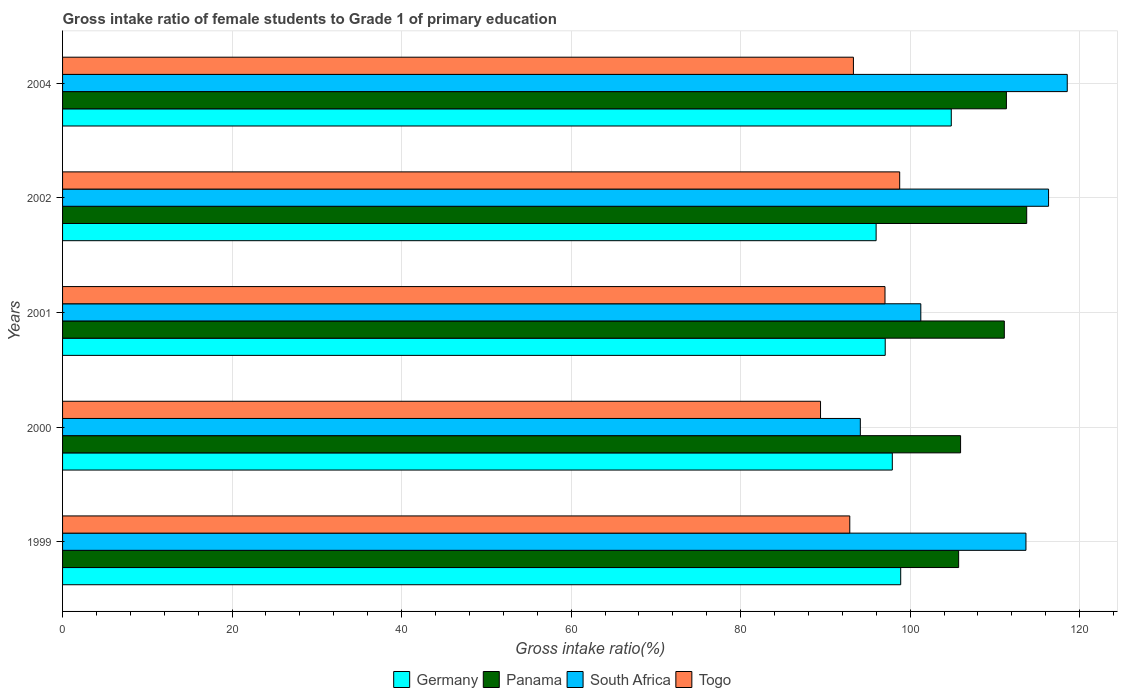How many groups of bars are there?
Make the answer very short. 5. Are the number of bars per tick equal to the number of legend labels?
Offer a very short reply. Yes. Are the number of bars on each tick of the Y-axis equal?
Your answer should be very brief. Yes. How many bars are there on the 1st tick from the top?
Make the answer very short. 4. What is the label of the 3rd group of bars from the top?
Provide a succinct answer. 2001. In how many cases, is the number of bars for a given year not equal to the number of legend labels?
Offer a terse response. 0. What is the gross intake ratio in Togo in 1999?
Provide a succinct answer. 92.88. Across all years, what is the maximum gross intake ratio in Germany?
Offer a very short reply. 104.85. Across all years, what is the minimum gross intake ratio in Panama?
Offer a very short reply. 105.72. In which year was the gross intake ratio in Togo maximum?
Offer a very short reply. 2002. In which year was the gross intake ratio in Panama minimum?
Your answer should be very brief. 1999. What is the total gross intake ratio in Germany in the graph?
Offer a terse response. 494.68. What is the difference between the gross intake ratio in Panama in 2000 and that in 2004?
Make the answer very short. -5.41. What is the difference between the gross intake ratio in Germany in 2004 and the gross intake ratio in South Africa in 2001?
Keep it short and to the point. 3.59. What is the average gross intake ratio in Togo per year?
Provide a short and direct response. 94.28. In the year 1999, what is the difference between the gross intake ratio in South Africa and gross intake ratio in Panama?
Your response must be concise. 7.94. In how many years, is the gross intake ratio in Togo greater than 48 %?
Provide a short and direct response. 5. What is the ratio of the gross intake ratio in Germany in 2001 to that in 2004?
Provide a short and direct response. 0.93. Is the gross intake ratio in Panama in 1999 less than that in 2001?
Offer a terse response. Yes. Is the difference between the gross intake ratio in South Africa in 2000 and 2002 greater than the difference between the gross intake ratio in Panama in 2000 and 2002?
Your answer should be very brief. No. What is the difference between the highest and the second highest gross intake ratio in South Africa?
Give a very brief answer. 2.21. What is the difference between the highest and the lowest gross intake ratio in Panama?
Provide a short and direct response. 8.03. In how many years, is the gross intake ratio in South Africa greater than the average gross intake ratio in South Africa taken over all years?
Your response must be concise. 3. Is the sum of the gross intake ratio in Panama in 1999 and 2004 greater than the maximum gross intake ratio in South Africa across all years?
Offer a very short reply. Yes. Is it the case that in every year, the sum of the gross intake ratio in Germany and gross intake ratio in Togo is greater than the sum of gross intake ratio in Panama and gross intake ratio in South Africa?
Provide a succinct answer. No. What does the 3rd bar from the top in 1999 represents?
Offer a very short reply. Panama. What does the 4th bar from the bottom in 2002 represents?
Your answer should be compact. Togo. How many bars are there?
Make the answer very short. 20. Does the graph contain grids?
Provide a succinct answer. Yes. How many legend labels are there?
Ensure brevity in your answer.  4. How are the legend labels stacked?
Ensure brevity in your answer.  Horizontal. What is the title of the graph?
Ensure brevity in your answer.  Gross intake ratio of female students to Grade 1 of primary education. What is the label or title of the X-axis?
Your answer should be very brief. Gross intake ratio(%). What is the Gross intake ratio(%) in Germany in 1999?
Your response must be concise. 98.89. What is the Gross intake ratio(%) of Panama in 1999?
Your answer should be very brief. 105.72. What is the Gross intake ratio(%) in South Africa in 1999?
Ensure brevity in your answer.  113.66. What is the Gross intake ratio(%) in Togo in 1999?
Your response must be concise. 92.88. What is the Gross intake ratio(%) of Germany in 2000?
Provide a short and direct response. 97.9. What is the Gross intake ratio(%) of Panama in 2000?
Make the answer very short. 105.95. What is the Gross intake ratio(%) of South Africa in 2000?
Offer a very short reply. 94.12. What is the Gross intake ratio(%) of Togo in 2000?
Offer a terse response. 89.43. What is the Gross intake ratio(%) in Germany in 2001?
Your answer should be very brief. 97.06. What is the Gross intake ratio(%) in Panama in 2001?
Offer a terse response. 111.11. What is the Gross intake ratio(%) in South Africa in 2001?
Offer a terse response. 101.26. What is the Gross intake ratio(%) in Togo in 2001?
Your answer should be compact. 97.03. What is the Gross intake ratio(%) in Germany in 2002?
Make the answer very short. 95.99. What is the Gross intake ratio(%) in Panama in 2002?
Your response must be concise. 113.75. What is the Gross intake ratio(%) in South Africa in 2002?
Ensure brevity in your answer.  116.33. What is the Gross intake ratio(%) in Togo in 2002?
Offer a terse response. 98.77. What is the Gross intake ratio(%) in Germany in 2004?
Your answer should be compact. 104.85. What is the Gross intake ratio(%) in Panama in 2004?
Ensure brevity in your answer.  111.36. What is the Gross intake ratio(%) in South Africa in 2004?
Give a very brief answer. 118.54. What is the Gross intake ratio(%) in Togo in 2004?
Ensure brevity in your answer.  93.31. Across all years, what is the maximum Gross intake ratio(%) of Germany?
Provide a short and direct response. 104.85. Across all years, what is the maximum Gross intake ratio(%) in Panama?
Give a very brief answer. 113.75. Across all years, what is the maximum Gross intake ratio(%) in South Africa?
Provide a succinct answer. 118.54. Across all years, what is the maximum Gross intake ratio(%) in Togo?
Ensure brevity in your answer.  98.77. Across all years, what is the minimum Gross intake ratio(%) in Germany?
Provide a succinct answer. 95.99. Across all years, what is the minimum Gross intake ratio(%) in Panama?
Your response must be concise. 105.72. Across all years, what is the minimum Gross intake ratio(%) in South Africa?
Provide a succinct answer. 94.12. Across all years, what is the minimum Gross intake ratio(%) of Togo?
Your answer should be compact. 89.43. What is the total Gross intake ratio(%) in Germany in the graph?
Provide a succinct answer. 494.68. What is the total Gross intake ratio(%) in Panama in the graph?
Offer a terse response. 547.89. What is the total Gross intake ratio(%) of South Africa in the graph?
Offer a terse response. 543.91. What is the total Gross intake ratio(%) in Togo in the graph?
Provide a short and direct response. 471.42. What is the difference between the Gross intake ratio(%) in Panama in 1999 and that in 2000?
Your response must be concise. -0.23. What is the difference between the Gross intake ratio(%) of South Africa in 1999 and that in 2000?
Keep it short and to the point. 19.54. What is the difference between the Gross intake ratio(%) in Togo in 1999 and that in 2000?
Your response must be concise. 3.45. What is the difference between the Gross intake ratio(%) in Germany in 1999 and that in 2001?
Your answer should be very brief. 1.83. What is the difference between the Gross intake ratio(%) in Panama in 1999 and that in 2001?
Offer a terse response. -5.39. What is the difference between the Gross intake ratio(%) of South Africa in 1999 and that in 2001?
Offer a terse response. 12.4. What is the difference between the Gross intake ratio(%) in Togo in 1999 and that in 2001?
Give a very brief answer. -4.15. What is the difference between the Gross intake ratio(%) in Germany in 1999 and that in 2002?
Give a very brief answer. 2.9. What is the difference between the Gross intake ratio(%) in Panama in 1999 and that in 2002?
Keep it short and to the point. -8.03. What is the difference between the Gross intake ratio(%) of South Africa in 1999 and that in 2002?
Provide a short and direct response. -2.67. What is the difference between the Gross intake ratio(%) in Togo in 1999 and that in 2002?
Make the answer very short. -5.89. What is the difference between the Gross intake ratio(%) of Germany in 1999 and that in 2004?
Your response must be concise. -5.97. What is the difference between the Gross intake ratio(%) in Panama in 1999 and that in 2004?
Give a very brief answer. -5.63. What is the difference between the Gross intake ratio(%) of South Africa in 1999 and that in 2004?
Make the answer very short. -4.87. What is the difference between the Gross intake ratio(%) of Togo in 1999 and that in 2004?
Offer a very short reply. -0.43. What is the difference between the Gross intake ratio(%) in Germany in 2000 and that in 2001?
Provide a succinct answer. 0.84. What is the difference between the Gross intake ratio(%) of Panama in 2000 and that in 2001?
Ensure brevity in your answer.  -5.16. What is the difference between the Gross intake ratio(%) in South Africa in 2000 and that in 2001?
Provide a succinct answer. -7.14. What is the difference between the Gross intake ratio(%) in Togo in 2000 and that in 2001?
Offer a terse response. -7.61. What is the difference between the Gross intake ratio(%) of Germany in 2000 and that in 2002?
Provide a succinct answer. 1.91. What is the difference between the Gross intake ratio(%) in Panama in 2000 and that in 2002?
Keep it short and to the point. -7.8. What is the difference between the Gross intake ratio(%) in South Africa in 2000 and that in 2002?
Make the answer very short. -22.21. What is the difference between the Gross intake ratio(%) of Togo in 2000 and that in 2002?
Your response must be concise. -9.34. What is the difference between the Gross intake ratio(%) of Germany in 2000 and that in 2004?
Give a very brief answer. -6.96. What is the difference between the Gross intake ratio(%) in Panama in 2000 and that in 2004?
Offer a terse response. -5.41. What is the difference between the Gross intake ratio(%) of South Africa in 2000 and that in 2004?
Offer a very short reply. -24.41. What is the difference between the Gross intake ratio(%) in Togo in 2000 and that in 2004?
Your response must be concise. -3.88. What is the difference between the Gross intake ratio(%) of Germany in 2001 and that in 2002?
Offer a very short reply. 1.07. What is the difference between the Gross intake ratio(%) in Panama in 2001 and that in 2002?
Your response must be concise. -2.64. What is the difference between the Gross intake ratio(%) in South Africa in 2001 and that in 2002?
Give a very brief answer. -15.07. What is the difference between the Gross intake ratio(%) in Togo in 2001 and that in 2002?
Make the answer very short. -1.73. What is the difference between the Gross intake ratio(%) of Germany in 2001 and that in 2004?
Your response must be concise. -7.79. What is the difference between the Gross intake ratio(%) in Panama in 2001 and that in 2004?
Provide a succinct answer. -0.25. What is the difference between the Gross intake ratio(%) of South Africa in 2001 and that in 2004?
Provide a short and direct response. -17.28. What is the difference between the Gross intake ratio(%) of Togo in 2001 and that in 2004?
Make the answer very short. 3.73. What is the difference between the Gross intake ratio(%) of Germany in 2002 and that in 2004?
Make the answer very short. -8.87. What is the difference between the Gross intake ratio(%) of Panama in 2002 and that in 2004?
Ensure brevity in your answer.  2.39. What is the difference between the Gross intake ratio(%) of South Africa in 2002 and that in 2004?
Ensure brevity in your answer.  -2.21. What is the difference between the Gross intake ratio(%) in Togo in 2002 and that in 2004?
Keep it short and to the point. 5.46. What is the difference between the Gross intake ratio(%) of Germany in 1999 and the Gross intake ratio(%) of Panama in 2000?
Ensure brevity in your answer.  -7.06. What is the difference between the Gross intake ratio(%) of Germany in 1999 and the Gross intake ratio(%) of South Africa in 2000?
Your answer should be compact. 4.76. What is the difference between the Gross intake ratio(%) of Germany in 1999 and the Gross intake ratio(%) of Togo in 2000?
Your answer should be very brief. 9.46. What is the difference between the Gross intake ratio(%) in Panama in 1999 and the Gross intake ratio(%) in South Africa in 2000?
Provide a short and direct response. 11.6. What is the difference between the Gross intake ratio(%) of Panama in 1999 and the Gross intake ratio(%) of Togo in 2000?
Ensure brevity in your answer.  16.3. What is the difference between the Gross intake ratio(%) of South Africa in 1999 and the Gross intake ratio(%) of Togo in 2000?
Keep it short and to the point. 24.24. What is the difference between the Gross intake ratio(%) in Germany in 1999 and the Gross intake ratio(%) in Panama in 2001?
Make the answer very short. -12.23. What is the difference between the Gross intake ratio(%) in Germany in 1999 and the Gross intake ratio(%) in South Africa in 2001?
Give a very brief answer. -2.37. What is the difference between the Gross intake ratio(%) of Germany in 1999 and the Gross intake ratio(%) of Togo in 2001?
Keep it short and to the point. 1.85. What is the difference between the Gross intake ratio(%) of Panama in 1999 and the Gross intake ratio(%) of South Africa in 2001?
Your answer should be compact. 4.46. What is the difference between the Gross intake ratio(%) of Panama in 1999 and the Gross intake ratio(%) of Togo in 2001?
Make the answer very short. 8.69. What is the difference between the Gross intake ratio(%) in South Africa in 1999 and the Gross intake ratio(%) in Togo in 2001?
Make the answer very short. 16.63. What is the difference between the Gross intake ratio(%) of Germany in 1999 and the Gross intake ratio(%) of Panama in 2002?
Give a very brief answer. -14.87. What is the difference between the Gross intake ratio(%) of Germany in 1999 and the Gross intake ratio(%) of South Africa in 2002?
Keep it short and to the point. -17.45. What is the difference between the Gross intake ratio(%) of Germany in 1999 and the Gross intake ratio(%) of Togo in 2002?
Offer a very short reply. 0.12. What is the difference between the Gross intake ratio(%) in Panama in 1999 and the Gross intake ratio(%) in South Africa in 2002?
Provide a short and direct response. -10.61. What is the difference between the Gross intake ratio(%) in Panama in 1999 and the Gross intake ratio(%) in Togo in 2002?
Offer a terse response. 6.96. What is the difference between the Gross intake ratio(%) in South Africa in 1999 and the Gross intake ratio(%) in Togo in 2002?
Keep it short and to the point. 14.9. What is the difference between the Gross intake ratio(%) of Germany in 1999 and the Gross intake ratio(%) of Panama in 2004?
Keep it short and to the point. -12.47. What is the difference between the Gross intake ratio(%) of Germany in 1999 and the Gross intake ratio(%) of South Africa in 2004?
Offer a terse response. -19.65. What is the difference between the Gross intake ratio(%) of Germany in 1999 and the Gross intake ratio(%) of Togo in 2004?
Keep it short and to the point. 5.58. What is the difference between the Gross intake ratio(%) in Panama in 1999 and the Gross intake ratio(%) in South Africa in 2004?
Your response must be concise. -12.81. What is the difference between the Gross intake ratio(%) in Panama in 1999 and the Gross intake ratio(%) in Togo in 2004?
Make the answer very short. 12.42. What is the difference between the Gross intake ratio(%) of South Africa in 1999 and the Gross intake ratio(%) of Togo in 2004?
Your answer should be very brief. 20.36. What is the difference between the Gross intake ratio(%) of Germany in 2000 and the Gross intake ratio(%) of Panama in 2001?
Offer a very short reply. -13.21. What is the difference between the Gross intake ratio(%) of Germany in 2000 and the Gross intake ratio(%) of South Africa in 2001?
Ensure brevity in your answer.  -3.36. What is the difference between the Gross intake ratio(%) in Germany in 2000 and the Gross intake ratio(%) in Togo in 2001?
Offer a very short reply. 0.86. What is the difference between the Gross intake ratio(%) of Panama in 2000 and the Gross intake ratio(%) of South Africa in 2001?
Your answer should be compact. 4.69. What is the difference between the Gross intake ratio(%) in Panama in 2000 and the Gross intake ratio(%) in Togo in 2001?
Give a very brief answer. 8.92. What is the difference between the Gross intake ratio(%) of South Africa in 2000 and the Gross intake ratio(%) of Togo in 2001?
Your response must be concise. -2.91. What is the difference between the Gross intake ratio(%) of Germany in 2000 and the Gross intake ratio(%) of Panama in 2002?
Ensure brevity in your answer.  -15.85. What is the difference between the Gross intake ratio(%) in Germany in 2000 and the Gross intake ratio(%) in South Africa in 2002?
Ensure brevity in your answer.  -18.43. What is the difference between the Gross intake ratio(%) in Germany in 2000 and the Gross intake ratio(%) in Togo in 2002?
Keep it short and to the point. -0.87. What is the difference between the Gross intake ratio(%) of Panama in 2000 and the Gross intake ratio(%) of South Africa in 2002?
Make the answer very short. -10.38. What is the difference between the Gross intake ratio(%) of Panama in 2000 and the Gross intake ratio(%) of Togo in 2002?
Provide a short and direct response. 7.18. What is the difference between the Gross intake ratio(%) of South Africa in 2000 and the Gross intake ratio(%) of Togo in 2002?
Make the answer very short. -4.64. What is the difference between the Gross intake ratio(%) of Germany in 2000 and the Gross intake ratio(%) of Panama in 2004?
Keep it short and to the point. -13.46. What is the difference between the Gross intake ratio(%) of Germany in 2000 and the Gross intake ratio(%) of South Africa in 2004?
Your answer should be compact. -20.64. What is the difference between the Gross intake ratio(%) of Germany in 2000 and the Gross intake ratio(%) of Togo in 2004?
Offer a terse response. 4.59. What is the difference between the Gross intake ratio(%) in Panama in 2000 and the Gross intake ratio(%) in South Africa in 2004?
Your answer should be compact. -12.59. What is the difference between the Gross intake ratio(%) in Panama in 2000 and the Gross intake ratio(%) in Togo in 2004?
Your response must be concise. 12.64. What is the difference between the Gross intake ratio(%) in South Africa in 2000 and the Gross intake ratio(%) in Togo in 2004?
Ensure brevity in your answer.  0.82. What is the difference between the Gross intake ratio(%) in Germany in 2001 and the Gross intake ratio(%) in Panama in 2002?
Your answer should be compact. -16.69. What is the difference between the Gross intake ratio(%) in Germany in 2001 and the Gross intake ratio(%) in South Africa in 2002?
Ensure brevity in your answer.  -19.27. What is the difference between the Gross intake ratio(%) of Germany in 2001 and the Gross intake ratio(%) of Togo in 2002?
Ensure brevity in your answer.  -1.71. What is the difference between the Gross intake ratio(%) of Panama in 2001 and the Gross intake ratio(%) of South Africa in 2002?
Keep it short and to the point. -5.22. What is the difference between the Gross intake ratio(%) in Panama in 2001 and the Gross intake ratio(%) in Togo in 2002?
Offer a very short reply. 12.34. What is the difference between the Gross intake ratio(%) of South Africa in 2001 and the Gross intake ratio(%) of Togo in 2002?
Your answer should be very brief. 2.49. What is the difference between the Gross intake ratio(%) of Germany in 2001 and the Gross intake ratio(%) of Panama in 2004?
Offer a terse response. -14.3. What is the difference between the Gross intake ratio(%) in Germany in 2001 and the Gross intake ratio(%) in South Africa in 2004?
Keep it short and to the point. -21.48. What is the difference between the Gross intake ratio(%) of Germany in 2001 and the Gross intake ratio(%) of Togo in 2004?
Your answer should be compact. 3.75. What is the difference between the Gross intake ratio(%) of Panama in 2001 and the Gross intake ratio(%) of South Africa in 2004?
Your answer should be compact. -7.43. What is the difference between the Gross intake ratio(%) of Panama in 2001 and the Gross intake ratio(%) of Togo in 2004?
Your answer should be very brief. 17.8. What is the difference between the Gross intake ratio(%) in South Africa in 2001 and the Gross intake ratio(%) in Togo in 2004?
Make the answer very short. 7.95. What is the difference between the Gross intake ratio(%) in Germany in 2002 and the Gross intake ratio(%) in Panama in 2004?
Make the answer very short. -15.37. What is the difference between the Gross intake ratio(%) of Germany in 2002 and the Gross intake ratio(%) of South Africa in 2004?
Offer a very short reply. -22.55. What is the difference between the Gross intake ratio(%) in Germany in 2002 and the Gross intake ratio(%) in Togo in 2004?
Your answer should be compact. 2.68. What is the difference between the Gross intake ratio(%) of Panama in 2002 and the Gross intake ratio(%) of South Africa in 2004?
Keep it short and to the point. -4.79. What is the difference between the Gross intake ratio(%) in Panama in 2002 and the Gross intake ratio(%) in Togo in 2004?
Your answer should be very brief. 20.44. What is the difference between the Gross intake ratio(%) in South Africa in 2002 and the Gross intake ratio(%) in Togo in 2004?
Make the answer very short. 23.02. What is the average Gross intake ratio(%) in Germany per year?
Your answer should be compact. 98.94. What is the average Gross intake ratio(%) in Panama per year?
Your answer should be compact. 109.58. What is the average Gross intake ratio(%) of South Africa per year?
Provide a short and direct response. 108.78. What is the average Gross intake ratio(%) of Togo per year?
Your answer should be compact. 94.28. In the year 1999, what is the difference between the Gross intake ratio(%) in Germany and Gross intake ratio(%) in Panama?
Your answer should be very brief. -6.84. In the year 1999, what is the difference between the Gross intake ratio(%) of Germany and Gross intake ratio(%) of South Africa?
Your answer should be compact. -14.78. In the year 1999, what is the difference between the Gross intake ratio(%) of Germany and Gross intake ratio(%) of Togo?
Your answer should be very brief. 6.01. In the year 1999, what is the difference between the Gross intake ratio(%) of Panama and Gross intake ratio(%) of South Africa?
Keep it short and to the point. -7.94. In the year 1999, what is the difference between the Gross intake ratio(%) of Panama and Gross intake ratio(%) of Togo?
Offer a terse response. 12.84. In the year 1999, what is the difference between the Gross intake ratio(%) in South Africa and Gross intake ratio(%) in Togo?
Provide a succinct answer. 20.78. In the year 2000, what is the difference between the Gross intake ratio(%) of Germany and Gross intake ratio(%) of Panama?
Provide a succinct answer. -8.05. In the year 2000, what is the difference between the Gross intake ratio(%) in Germany and Gross intake ratio(%) in South Africa?
Provide a succinct answer. 3.77. In the year 2000, what is the difference between the Gross intake ratio(%) of Germany and Gross intake ratio(%) of Togo?
Your answer should be compact. 8.47. In the year 2000, what is the difference between the Gross intake ratio(%) in Panama and Gross intake ratio(%) in South Africa?
Provide a short and direct response. 11.83. In the year 2000, what is the difference between the Gross intake ratio(%) in Panama and Gross intake ratio(%) in Togo?
Offer a terse response. 16.52. In the year 2000, what is the difference between the Gross intake ratio(%) of South Africa and Gross intake ratio(%) of Togo?
Your answer should be compact. 4.7. In the year 2001, what is the difference between the Gross intake ratio(%) in Germany and Gross intake ratio(%) in Panama?
Offer a terse response. -14.05. In the year 2001, what is the difference between the Gross intake ratio(%) in Germany and Gross intake ratio(%) in South Africa?
Offer a terse response. -4.2. In the year 2001, what is the difference between the Gross intake ratio(%) of Germany and Gross intake ratio(%) of Togo?
Your response must be concise. 0.03. In the year 2001, what is the difference between the Gross intake ratio(%) in Panama and Gross intake ratio(%) in South Africa?
Provide a succinct answer. 9.85. In the year 2001, what is the difference between the Gross intake ratio(%) in Panama and Gross intake ratio(%) in Togo?
Your answer should be very brief. 14.08. In the year 2001, what is the difference between the Gross intake ratio(%) of South Africa and Gross intake ratio(%) of Togo?
Your answer should be compact. 4.22. In the year 2002, what is the difference between the Gross intake ratio(%) of Germany and Gross intake ratio(%) of Panama?
Your response must be concise. -17.77. In the year 2002, what is the difference between the Gross intake ratio(%) of Germany and Gross intake ratio(%) of South Africa?
Your response must be concise. -20.34. In the year 2002, what is the difference between the Gross intake ratio(%) of Germany and Gross intake ratio(%) of Togo?
Provide a short and direct response. -2.78. In the year 2002, what is the difference between the Gross intake ratio(%) in Panama and Gross intake ratio(%) in South Africa?
Keep it short and to the point. -2.58. In the year 2002, what is the difference between the Gross intake ratio(%) of Panama and Gross intake ratio(%) of Togo?
Ensure brevity in your answer.  14.98. In the year 2002, what is the difference between the Gross intake ratio(%) in South Africa and Gross intake ratio(%) in Togo?
Your response must be concise. 17.56. In the year 2004, what is the difference between the Gross intake ratio(%) of Germany and Gross intake ratio(%) of Panama?
Give a very brief answer. -6.5. In the year 2004, what is the difference between the Gross intake ratio(%) in Germany and Gross intake ratio(%) in South Africa?
Your answer should be very brief. -13.68. In the year 2004, what is the difference between the Gross intake ratio(%) of Germany and Gross intake ratio(%) of Togo?
Your answer should be very brief. 11.55. In the year 2004, what is the difference between the Gross intake ratio(%) of Panama and Gross intake ratio(%) of South Africa?
Make the answer very short. -7.18. In the year 2004, what is the difference between the Gross intake ratio(%) in Panama and Gross intake ratio(%) in Togo?
Your response must be concise. 18.05. In the year 2004, what is the difference between the Gross intake ratio(%) of South Africa and Gross intake ratio(%) of Togo?
Ensure brevity in your answer.  25.23. What is the ratio of the Gross intake ratio(%) in Panama in 1999 to that in 2000?
Make the answer very short. 1. What is the ratio of the Gross intake ratio(%) of South Africa in 1999 to that in 2000?
Ensure brevity in your answer.  1.21. What is the ratio of the Gross intake ratio(%) of Togo in 1999 to that in 2000?
Your answer should be compact. 1.04. What is the ratio of the Gross intake ratio(%) in Germany in 1999 to that in 2001?
Keep it short and to the point. 1.02. What is the ratio of the Gross intake ratio(%) in Panama in 1999 to that in 2001?
Ensure brevity in your answer.  0.95. What is the ratio of the Gross intake ratio(%) of South Africa in 1999 to that in 2001?
Your answer should be very brief. 1.12. What is the ratio of the Gross intake ratio(%) in Togo in 1999 to that in 2001?
Provide a succinct answer. 0.96. What is the ratio of the Gross intake ratio(%) in Germany in 1999 to that in 2002?
Provide a succinct answer. 1.03. What is the ratio of the Gross intake ratio(%) in Panama in 1999 to that in 2002?
Make the answer very short. 0.93. What is the ratio of the Gross intake ratio(%) in South Africa in 1999 to that in 2002?
Offer a terse response. 0.98. What is the ratio of the Gross intake ratio(%) in Togo in 1999 to that in 2002?
Provide a succinct answer. 0.94. What is the ratio of the Gross intake ratio(%) in Germany in 1999 to that in 2004?
Make the answer very short. 0.94. What is the ratio of the Gross intake ratio(%) in Panama in 1999 to that in 2004?
Your response must be concise. 0.95. What is the ratio of the Gross intake ratio(%) in South Africa in 1999 to that in 2004?
Offer a very short reply. 0.96. What is the ratio of the Gross intake ratio(%) in Togo in 1999 to that in 2004?
Provide a succinct answer. 1. What is the ratio of the Gross intake ratio(%) of Germany in 2000 to that in 2001?
Provide a short and direct response. 1.01. What is the ratio of the Gross intake ratio(%) in Panama in 2000 to that in 2001?
Give a very brief answer. 0.95. What is the ratio of the Gross intake ratio(%) in South Africa in 2000 to that in 2001?
Your response must be concise. 0.93. What is the ratio of the Gross intake ratio(%) in Togo in 2000 to that in 2001?
Provide a short and direct response. 0.92. What is the ratio of the Gross intake ratio(%) of Germany in 2000 to that in 2002?
Give a very brief answer. 1.02. What is the ratio of the Gross intake ratio(%) in Panama in 2000 to that in 2002?
Make the answer very short. 0.93. What is the ratio of the Gross intake ratio(%) of South Africa in 2000 to that in 2002?
Provide a short and direct response. 0.81. What is the ratio of the Gross intake ratio(%) in Togo in 2000 to that in 2002?
Keep it short and to the point. 0.91. What is the ratio of the Gross intake ratio(%) of Germany in 2000 to that in 2004?
Your answer should be very brief. 0.93. What is the ratio of the Gross intake ratio(%) in Panama in 2000 to that in 2004?
Offer a very short reply. 0.95. What is the ratio of the Gross intake ratio(%) of South Africa in 2000 to that in 2004?
Your response must be concise. 0.79. What is the ratio of the Gross intake ratio(%) in Togo in 2000 to that in 2004?
Make the answer very short. 0.96. What is the ratio of the Gross intake ratio(%) in Germany in 2001 to that in 2002?
Make the answer very short. 1.01. What is the ratio of the Gross intake ratio(%) in Panama in 2001 to that in 2002?
Your answer should be very brief. 0.98. What is the ratio of the Gross intake ratio(%) in South Africa in 2001 to that in 2002?
Keep it short and to the point. 0.87. What is the ratio of the Gross intake ratio(%) of Togo in 2001 to that in 2002?
Your response must be concise. 0.98. What is the ratio of the Gross intake ratio(%) in Germany in 2001 to that in 2004?
Your response must be concise. 0.93. What is the ratio of the Gross intake ratio(%) in South Africa in 2001 to that in 2004?
Your response must be concise. 0.85. What is the ratio of the Gross intake ratio(%) of Togo in 2001 to that in 2004?
Offer a very short reply. 1.04. What is the ratio of the Gross intake ratio(%) in Germany in 2002 to that in 2004?
Offer a very short reply. 0.92. What is the ratio of the Gross intake ratio(%) in Panama in 2002 to that in 2004?
Provide a succinct answer. 1.02. What is the ratio of the Gross intake ratio(%) of South Africa in 2002 to that in 2004?
Give a very brief answer. 0.98. What is the ratio of the Gross intake ratio(%) of Togo in 2002 to that in 2004?
Your answer should be very brief. 1.06. What is the difference between the highest and the second highest Gross intake ratio(%) of Germany?
Ensure brevity in your answer.  5.97. What is the difference between the highest and the second highest Gross intake ratio(%) in Panama?
Keep it short and to the point. 2.39. What is the difference between the highest and the second highest Gross intake ratio(%) in South Africa?
Keep it short and to the point. 2.21. What is the difference between the highest and the second highest Gross intake ratio(%) in Togo?
Give a very brief answer. 1.73. What is the difference between the highest and the lowest Gross intake ratio(%) in Germany?
Make the answer very short. 8.87. What is the difference between the highest and the lowest Gross intake ratio(%) in Panama?
Your response must be concise. 8.03. What is the difference between the highest and the lowest Gross intake ratio(%) of South Africa?
Offer a terse response. 24.41. What is the difference between the highest and the lowest Gross intake ratio(%) in Togo?
Keep it short and to the point. 9.34. 